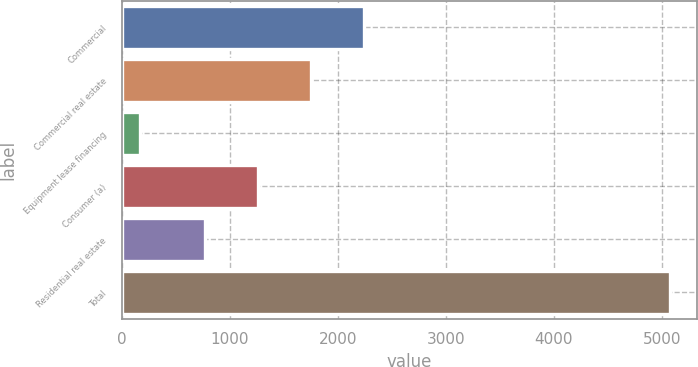<chart> <loc_0><loc_0><loc_500><loc_500><bar_chart><fcel>Commercial<fcel>Commercial real estate<fcel>Equipment lease financing<fcel>Consumer (a)<fcel>Residential real estate<fcel>Total<nl><fcel>2240.3<fcel>1750.2<fcel>171<fcel>1260.1<fcel>770<fcel>5072<nl></chart> 